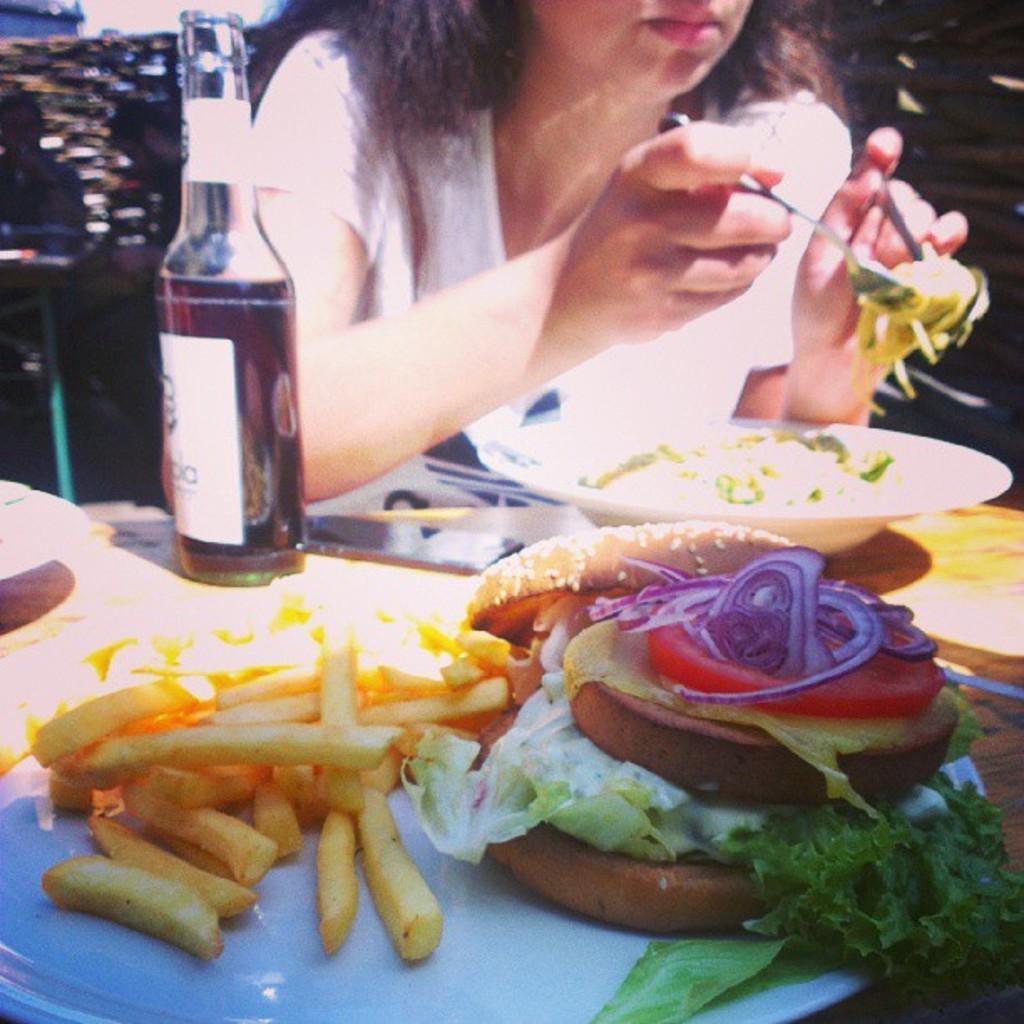Could you give a brief overview of what you see in this image? In this picture we can see a women sitting on a chair in front of a table and she is holding a food with spoons in her hand. On the table we can see french fries , burger and bottle. 